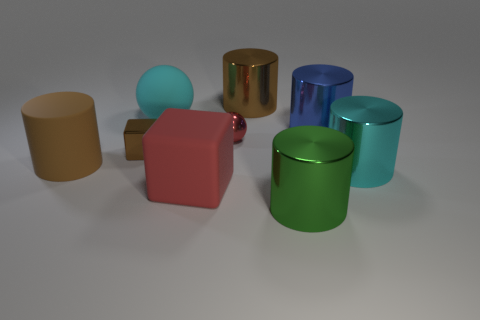Are there any tiny yellow cylinders that have the same material as the large red cube?
Provide a succinct answer. No. There is a cyan thing in front of the large brown matte object; does it have the same shape as the brown metallic thing left of the red metal thing?
Offer a very short reply. No. Are any green rubber balls visible?
Give a very brief answer. No. There is a shiny ball that is the same size as the shiny cube; what is its color?
Make the answer very short. Red. What number of cyan metal objects are the same shape as the large blue object?
Your response must be concise. 1. Is the material of the cylinder on the left side of the big red matte object the same as the big cyan cylinder?
Your response must be concise. No. How many blocks are large green metal objects or cyan things?
Make the answer very short. 0. What shape is the large cyan thing right of the large brown cylinder that is on the right side of the brown cylinder that is on the left side of the large red object?
Ensure brevity in your answer.  Cylinder. There is a rubber thing that is the same color as the shiny ball; what is its shape?
Ensure brevity in your answer.  Cube. How many brown matte things have the same size as the red metallic object?
Your answer should be compact. 0. 